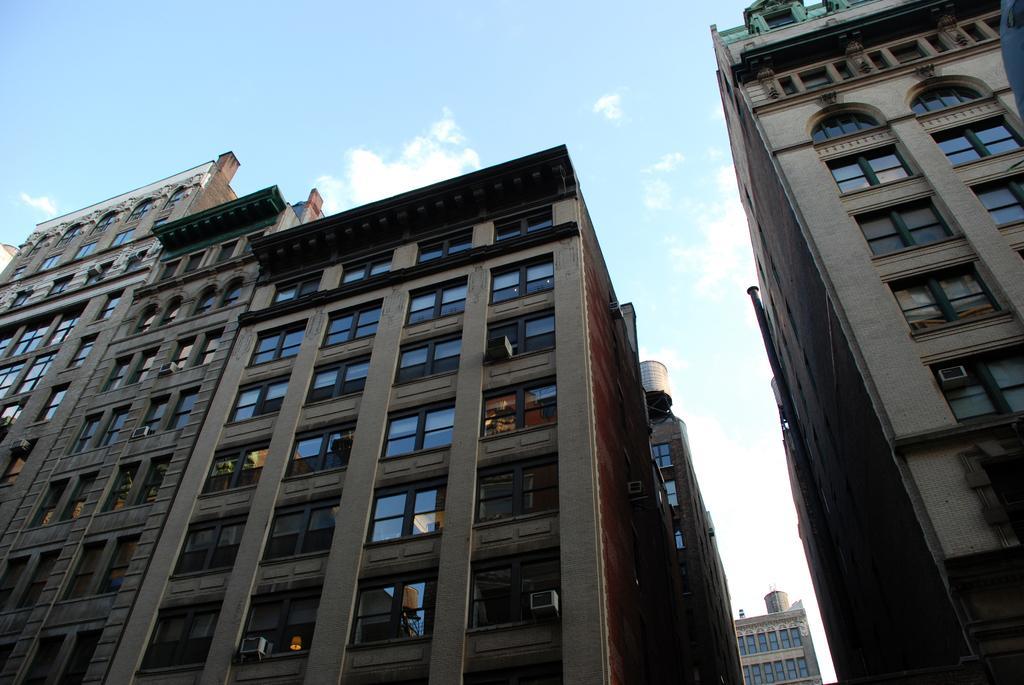Could you give a brief overview of what you see in this image? In this image I can see few buildings along with the windows. At the top of the image I can see the sky and clouds. 